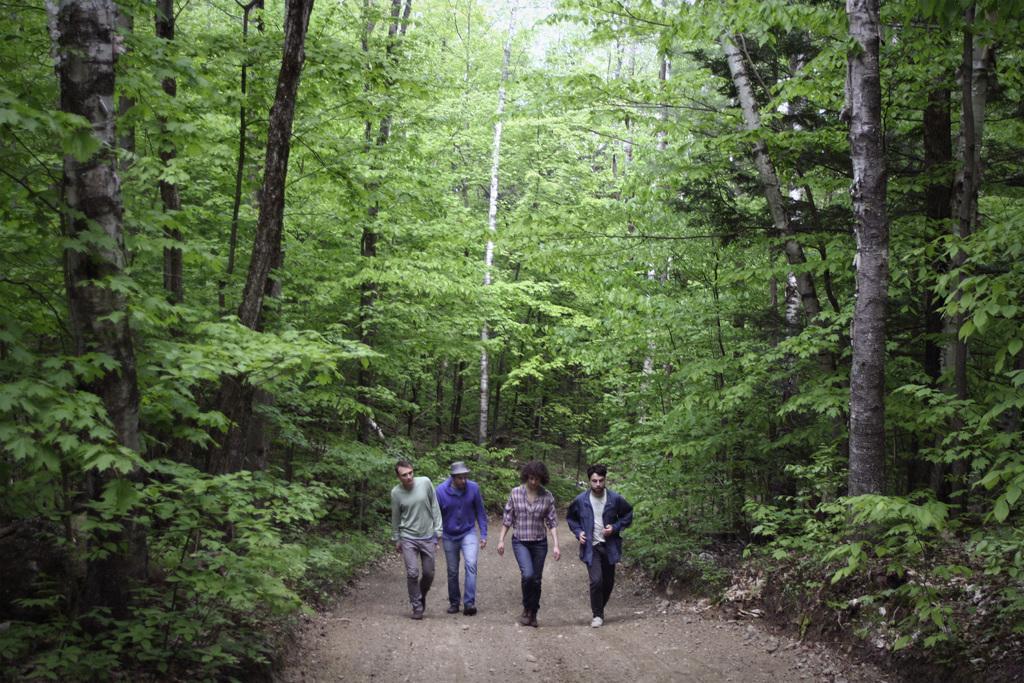Can you describe this image briefly? In this picture we can see people on the ground and in the background we can see trees. 